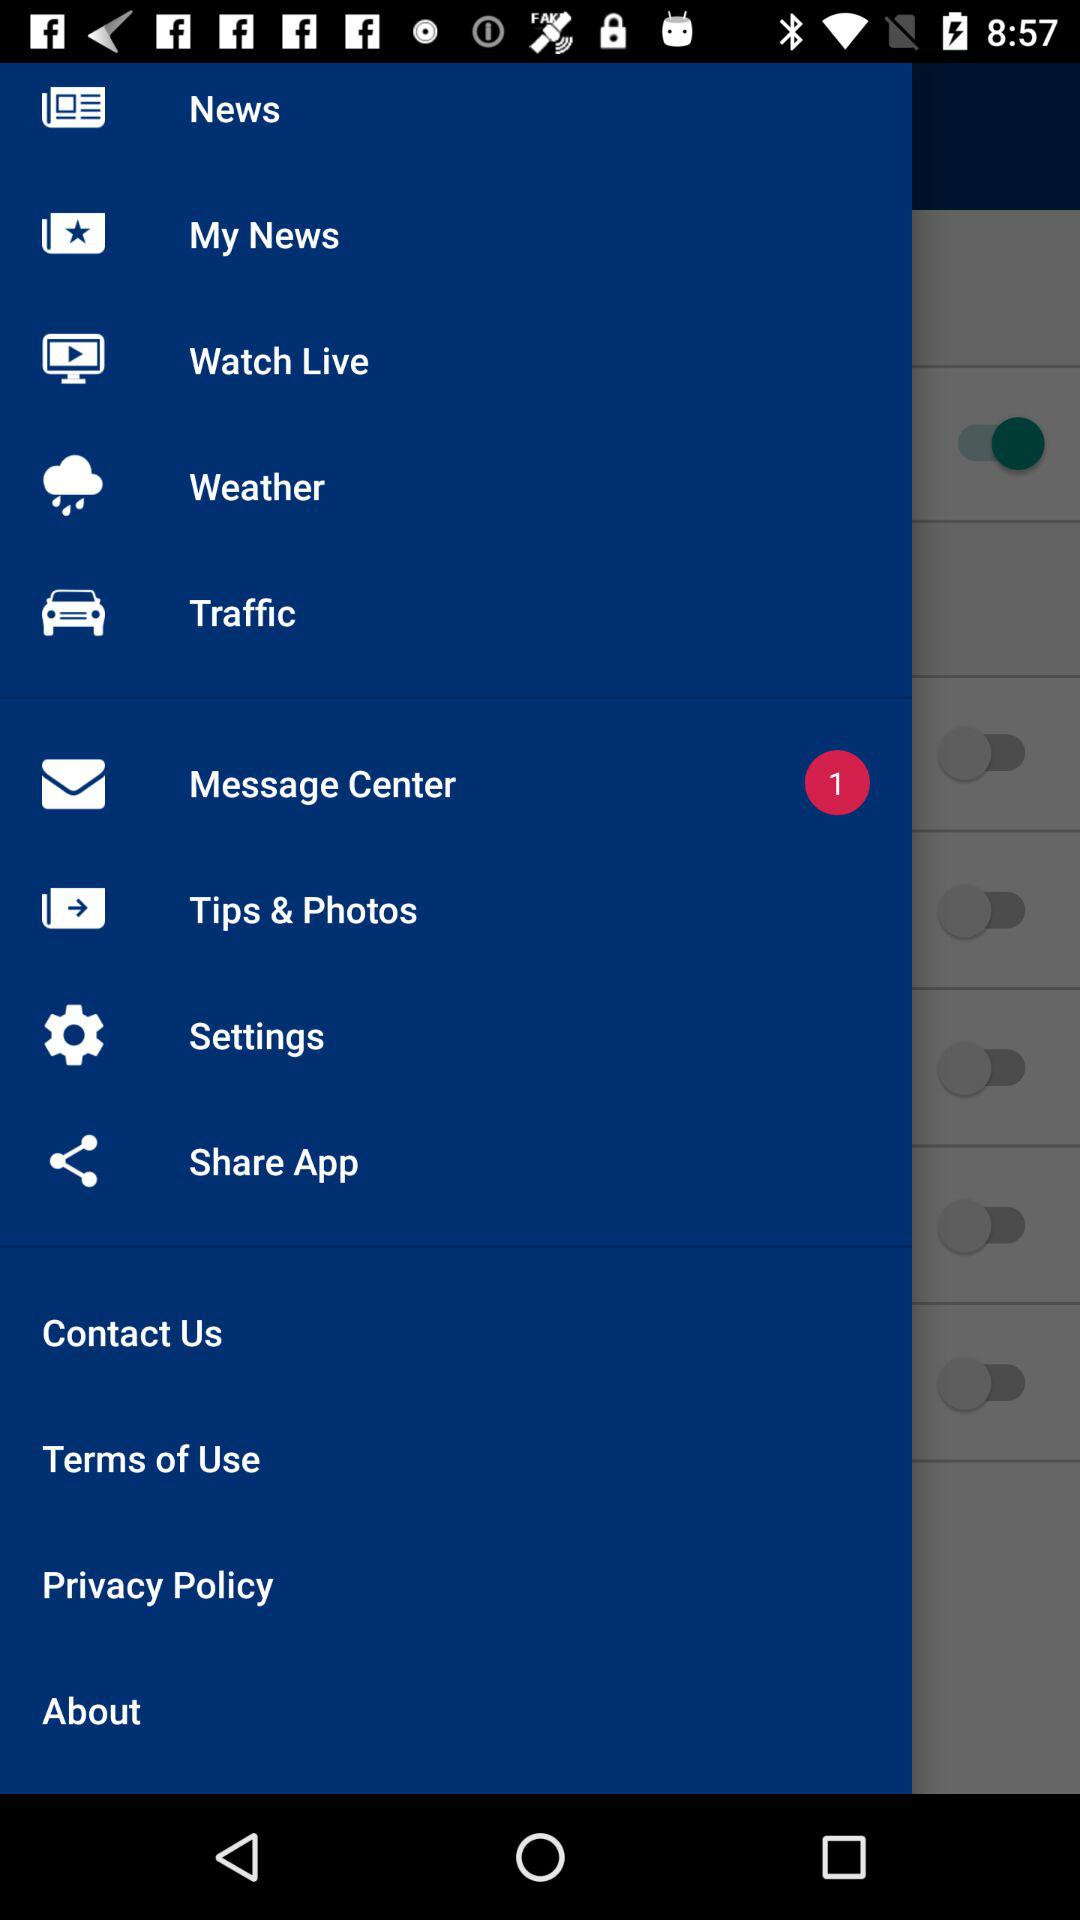How many messages were unread? There was 1 unread message. 